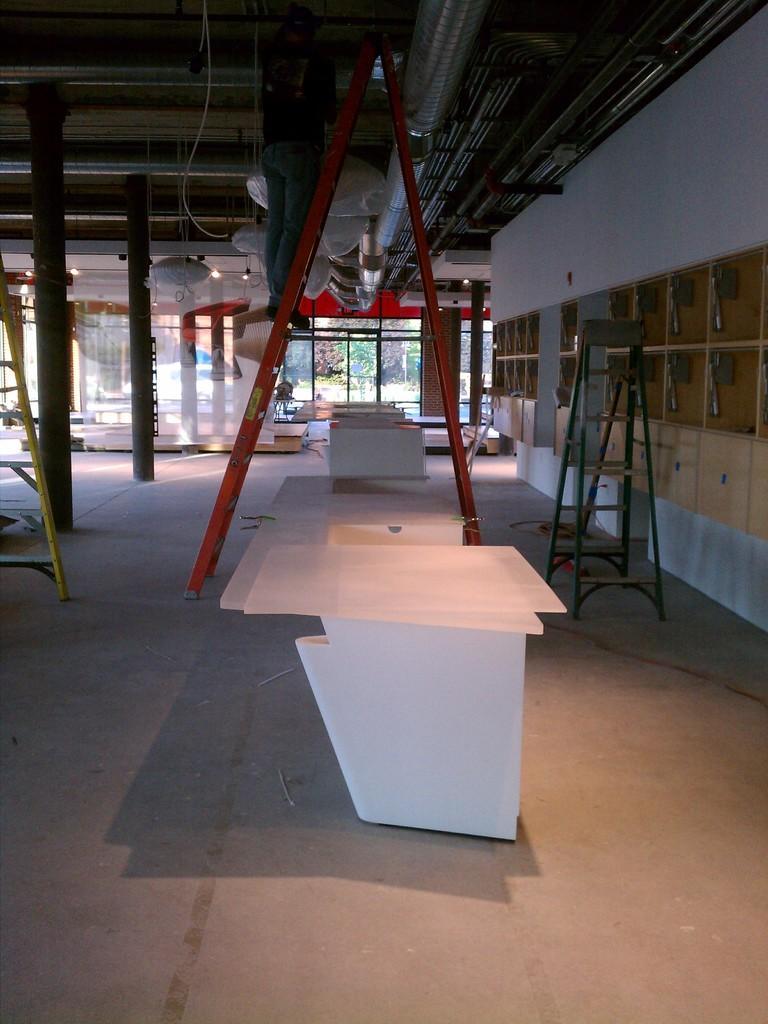Please provide a concise description of this image. In this image there are tables and ladders are on the floor. Behind them there are few windows from which few trees are visible. There are few pillars. 